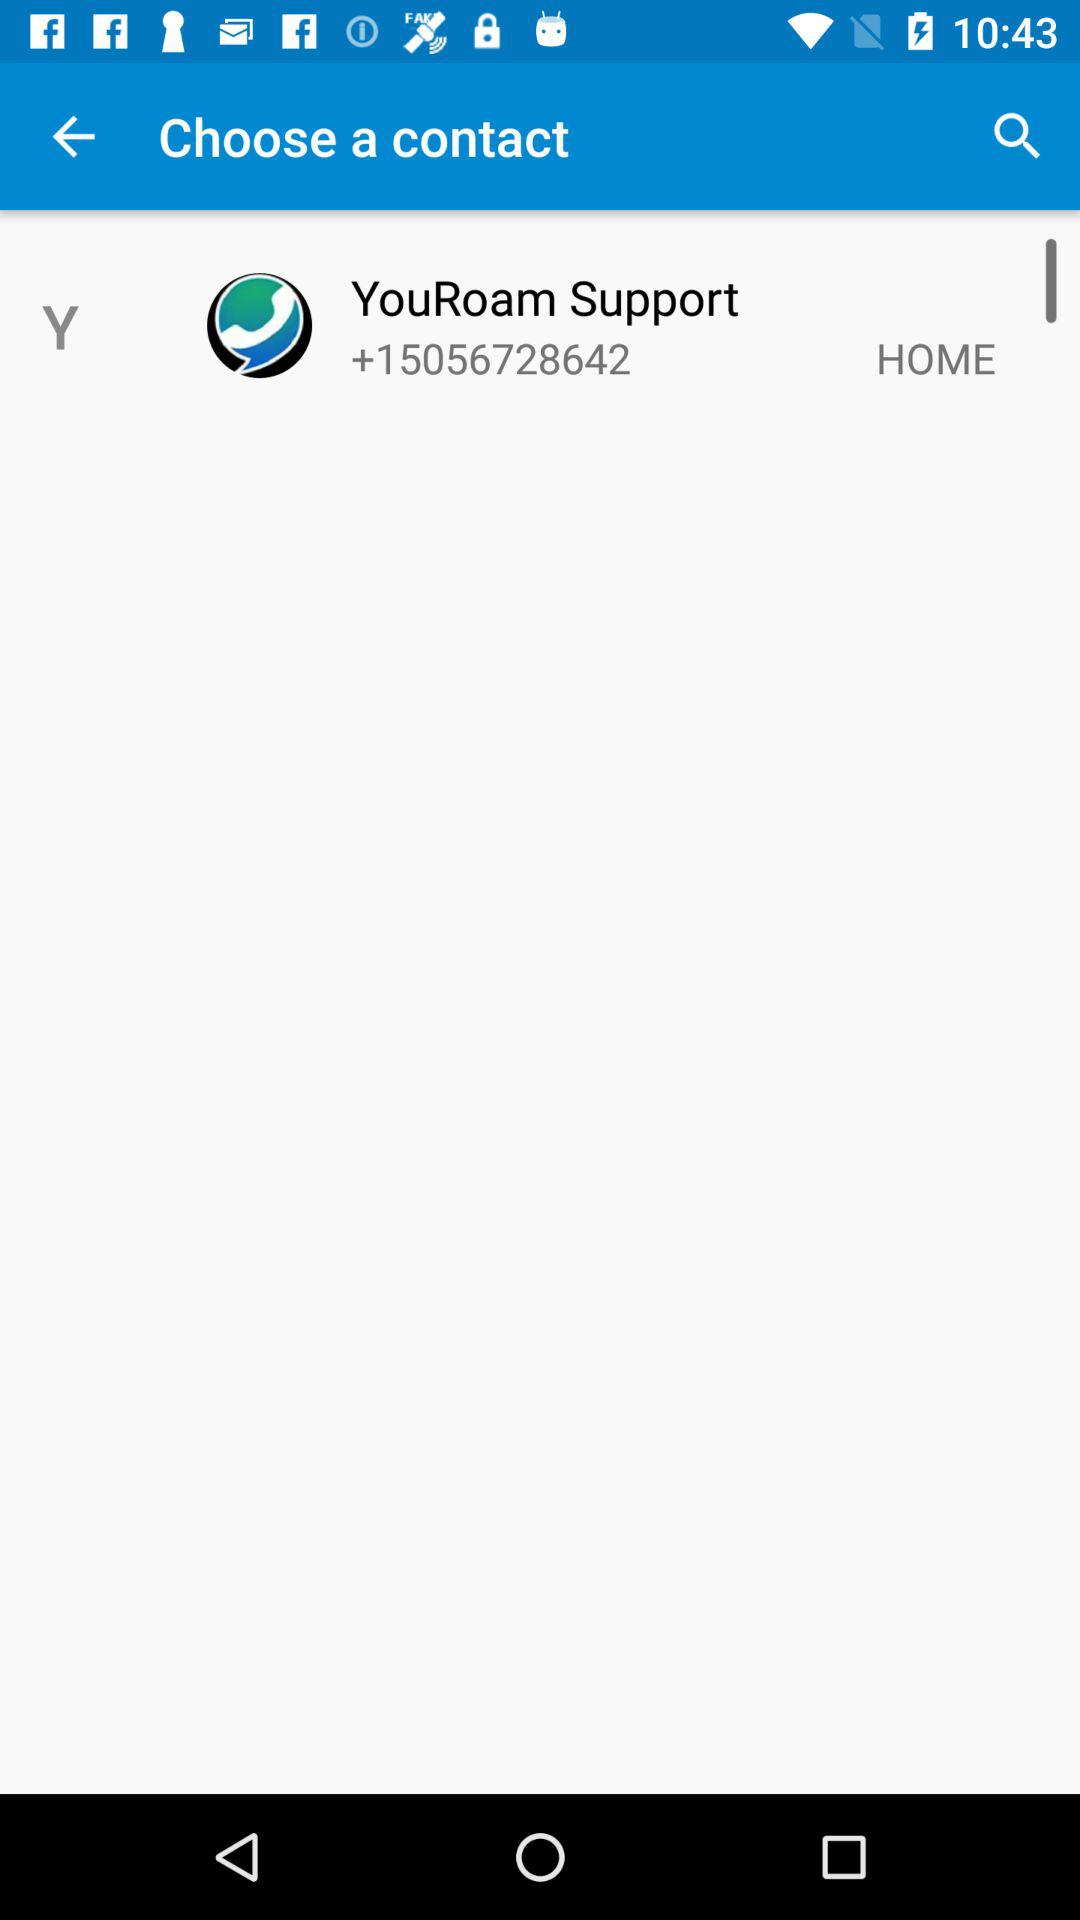Where can I email the "YouRoam" support staff?
When the provided information is insufficient, respond with <no answer>. <no answer> 